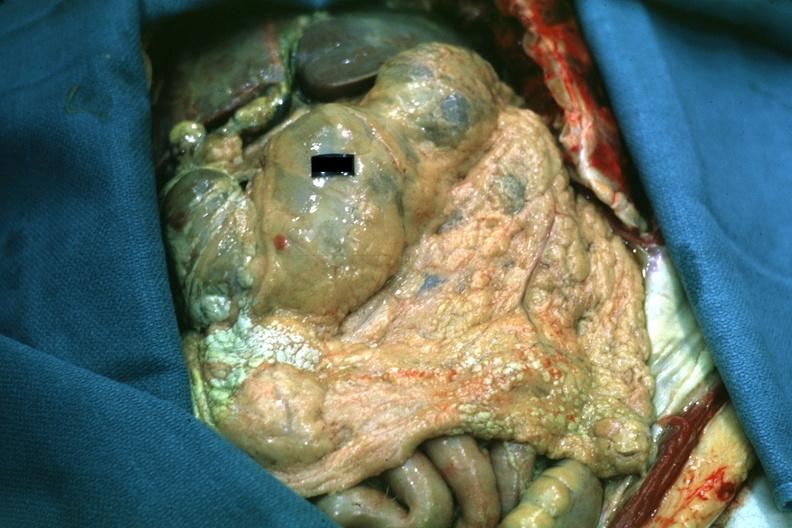s fat necrosis present?
Answer the question using a single word or phrase. Yes 